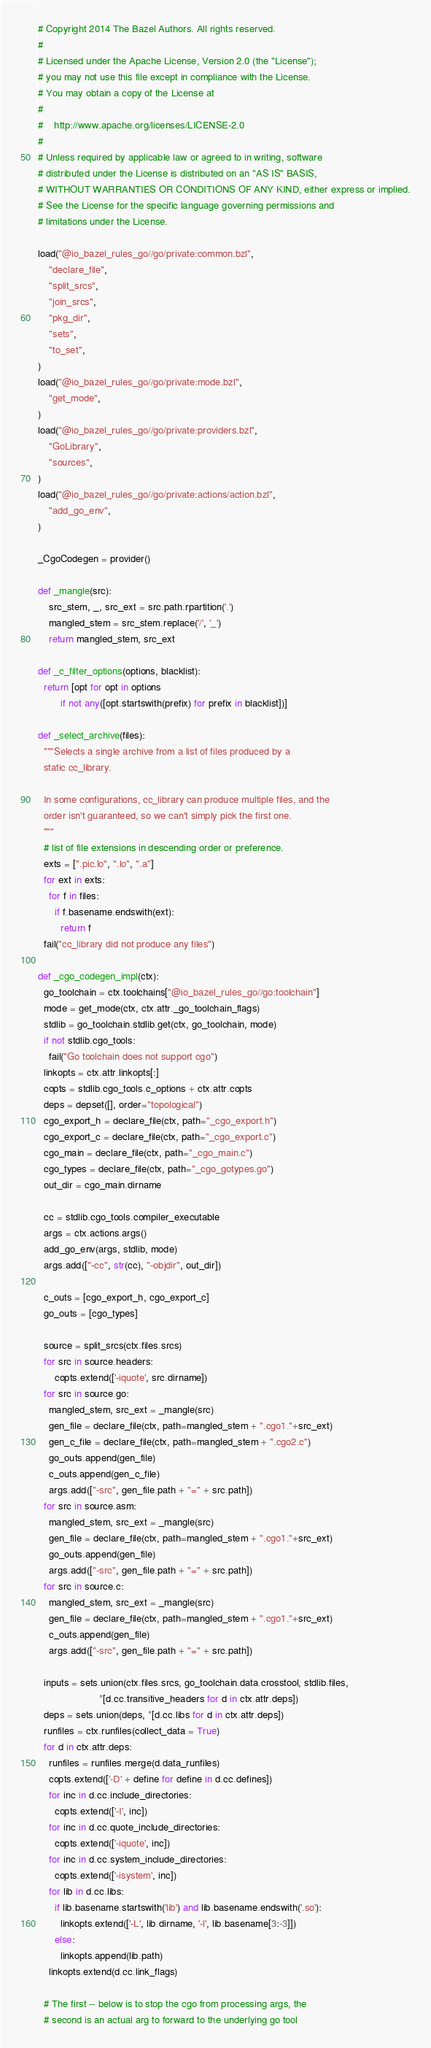<code> <loc_0><loc_0><loc_500><loc_500><_Python_># Copyright 2014 The Bazel Authors. All rights reserved.
#
# Licensed under the Apache License, Version 2.0 (the "License");
# you may not use this file except in compliance with the License.
# You may obtain a copy of the License at
#
#    http://www.apache.org/licenses/LICENSE-2.0
#
# Unless required by applicable law or agreed to in writing, software
# distributed under the License is distributed on an "AS IS" BASIS,
# WITHOUT WARRANTIES OR CONDITIONS OF ANY KIND, either express or implied.
# See the License for the specific language governing permissions and
# limitations under the License.

load("@io_bazel_rules_go//go/private:common.bzl",
    "declare_file",
    "split_srcs",
    "join_srcs",
    "pkg_dir",
    "sets",
    "to_set",
)
load("@io_bazel_rules_go//go/private:mode.bzl",
    "get_mode",
)
load("@io_bazel_rules_go//go/private:providers.bzl",
    "GoLibrary",
    "sources",
)
load("@io_bazel_rules_go//go/private:actions/action.bzl",
    "add_go_env",
)

_CgoCodegen = provider()

def _mangle(src):
    src_stem, _, src_ext = src.path.rpartition('.')
    mangled_stem = src_stem.replace('/', '_')
    return mangled_stem, src_ext

def _c_filter_options(options, blacklist):
  return [opt for opt in options
        if not any([opt.startswith(prefix) for prefix in blacklist])]

def _select_archive(files):
  """Selects a single archive from a list of files produced by a
  static cc_library.

  In some configurations, cc_library can produce multiple files, and the
  order isn't guaranteed, so we can't simply pick the first one.
  """
  # list of file extensions in descending order or preference.
  exts = [".pic.lo", ".lo", ".a"]
  for ext in exts:
    for f in files:
      if f.basename.endswith(ext):
        return f
  fail("cc_library did not produce any files")

def _cgo_codegen_impl(ctx):
  go_toolchain = ctx.toolchains["@io_bazel_rules_go//go:toolchain"]
  mode = get_mode(ctx, ctx.attr._go_toolchain_flags)
  stdlib = go_toolchain.stdlib.get(ctx, go_toolchain, mode)
  if not stdlib.cgo_tools:
    fail("Go toolchain does not support cgo")
  linkopts = ctx.attr.linkopts[:]
  copts = stdlib.cgo_tools.c_options + ctx.attr.copts
  deps = depset([], order="topological")
  cgo_export_h = declare_file(ctx, path="_cgo_export.h")
  cgo_export_c = declare_file(ctx, path="_cgo_export.c")
  cgo_main = declare_file(ctx, path="_cgo_main.c")
  cgo_types = declare_file(ctx, path="_cgo_gotypes.go")
  out_dir = cgo_main.dirname

  cc = stdlib.cgo_tools.compiler_executable
  args = ctx.actions.args()
  add_go_env(args, stdlib, mode)
  args.add(["-cc", str(cc), "-objdir", out_dir])

  c_outs = [cgo_export_h, cgo_export_c]
  go_outs = [cgo_types]

  source = split_srcs(ctx.files.srcs)
  for src in source.headers:
      copts.extend(['-iquote', src.dirname])
  for src in source.go:
    mangled_stem, src_ext = _mangle(src)
    gen_file = declare_file(ctx, path=mangled_stem + ".cgo1."+src_ext)
    gen_c_file = declare_file(ctx, path=mangled_stem + ".cgo2.c")
    go_outs.append(gen_file)
    c_outs.append(gen_c_file)
    args.add(["-src", gen_file.path + "=" + src.path])
  for src in source.asm:
    mangled_stem, src_ext = _mangle(src)
    gen_file = declare_file(ctx, path=mangled_stem + ".cgo1."+src_ext)
    go_outs.append(gen_file)
    args.add(["-src", gen_file.path + "=" + src.path])
  for src in source.c:
    mangled_stem, src_ext = _mangle(src)
    gen_file = declare_file(ctx, path=mangled_stem + ".cgo1."+src_ext)
    c_outs.append(gen_file)
    args.add(["-src", gen_file.path + "=" + src.path])

  inputs = sets.union(ctx.files.srcs, go_toolchain.data.crosstool, stdlib.files,
                      *[d.cc.transitive_headers for d in ctx.attr.deps])
  deps = sets.union(deps, *[d.cc.libs for d in ctx.attr.deps])
  runfiles = ctx.runfiles(collect_data = True)
  for d in ctx.attr.deps:
    runfiles = runfiles.merge(d.data_runfiles)
    copts.extend(['-D' + define for define in d.cc.defines])
    for inc in d.cc.include_directories:
      copts.extend(['-I', inc])
    for inc in d.cc.quote_include_directories:
      copts.extend(['-iquote', inc])
    for inc in d.cc.system_include_directories:
      copts.extend(['-isystem', inc])
    for lib in d.cc.libs:
      if lib.basename.startswith('lib') and lib.basename.endswith('.so'):
        linkopts.extend(['-L', lib.dirname, '-l', lib.basename[3:-3]])
      else:
        linkopts.append(lib.path)
    linkopts.extend(d.cc.link_flags)

  # The first -- below is to stop the cgo from processing args, the
  # second is an actual arg to forward to the underlying go tool</code> 